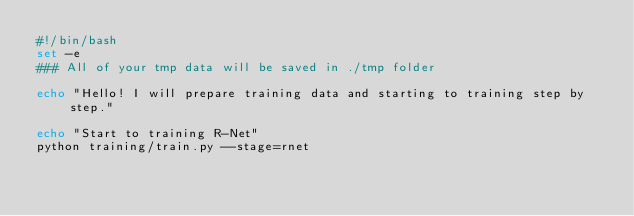<code> <loc_0><loc_0><loc_500><loc_500><_Bash_>#!/bin/bash
set -e
### All of your tmp data will be saved in ./tmp folder

echo "Hello! I will prepare training data and starting to training step by step."

echo "Start to training R-Net"
python training/train.py --stage=rnet


</code> 